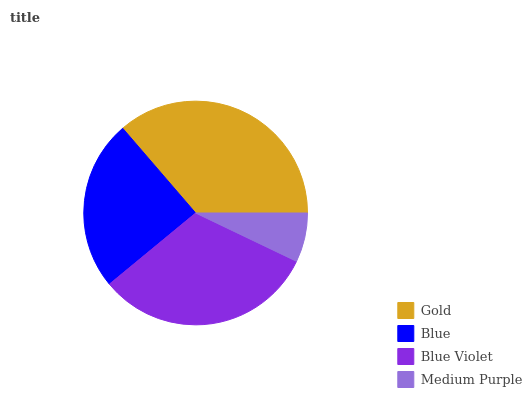Is Medium Purple the minimum?
Answer yes or no. Yes. Is Gold the maximum?
Answer yes or no. Yes. Is Blue the minimum?
Answer yes or no. No. Is Blue the maximum?
Answer yes or no. No. Is Gold greater than Blue?
Answer yes or no. Yes. Is Blue less than Gold?
Answer yes or no. Yes. Is Blue greater than Gold?
Answer yes or no. No. Is Gold less than Blue?
Answer yes or no. No. Is Blue Violet the high median?
Answer yes or no. Yes. Is Blue the low median?
Answer yes or no. Yes. Is Blue the high median?
Answer yes or no. No. Is Blue Violet the low median?
Answer yes or no. No. 